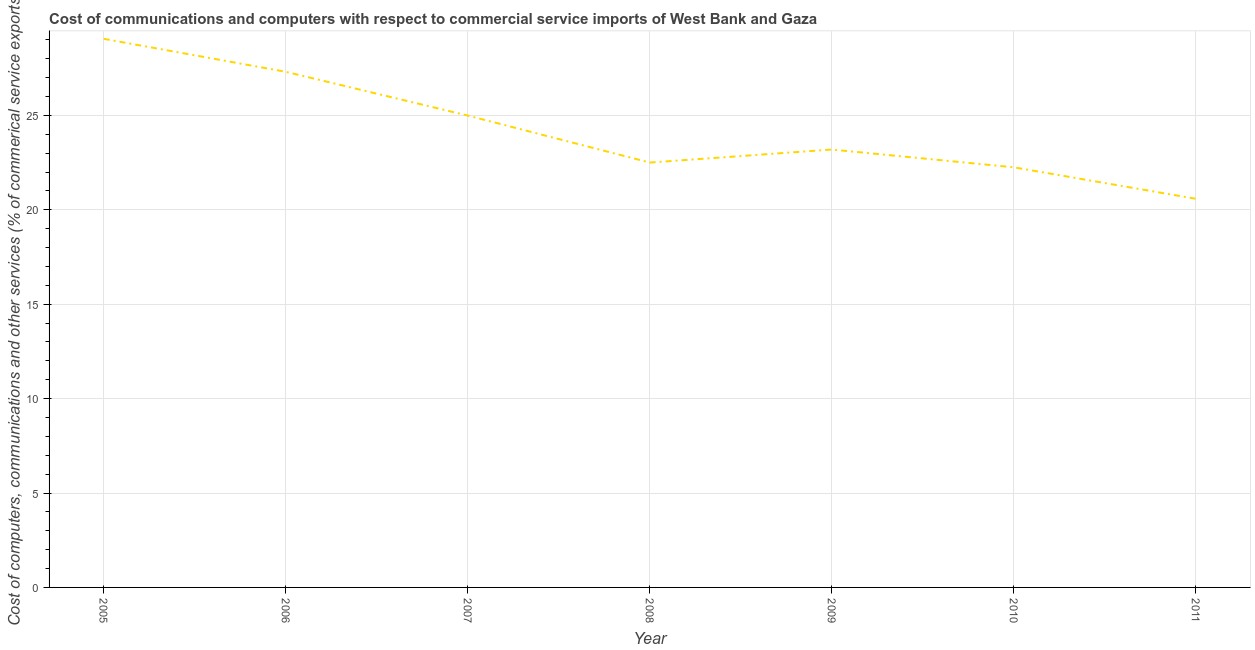What is the  computer and other services in 2011?
Keep it short and to the point. 20.58. Across all years, what is the maximum  computer and other services?
Your answer should be very brief. 29.06. Across all years, what is the minimum cost of communications?
Offer a terse response. 20.58. In which year was the  computer and other services minimum?
Make the answer very short. 2011. What is the sum of the  computer and other services?
Provide a short and direct response. 169.9. What is the difference between the cost of communications in 2005 and 2009?
Offer a terse response. 5.86. What is the average cost of communications per year?
Your answer should be very brief. 24.27. What is the median  computer and other services?
Keep it short and to the point. 23.19. In how many years, is the  computer and other services greater than 5 %?
Offer a terse response. 7. What is the ratio of the cost of communications in 2005 to that in 2010?
Make the answer very short. 1.31. What is the difference between the highest and the second highest cost of communications?
Your answer should be very brief. 1.75. Is the sum of the cost of communications in 2007 and 2008 greater than the maximum cost of communications across all years?
Your answer should be compact. Yes. What is the difference between the highest and the lowest  computer and other services?
Offer a very short reply. 8.47. How many years are there in the graph?
Give a very brief answer. 7. What is the difference between two consecutive major ticks on the Y-axis?
Keep it short and to the point. 5. Are the values on the major ticks of Y-axis written in scientific E-notation?
Give a very brief answer. No. Does the graph contain grids?
Make the answer very short. Yes. What is the title of the graph?
Give a very brief answer. Cost of communications and computers with respect to commercial service imports of West Bank and Gaza. What is the label or title of the X-axis?
Provide a short and direct response. Year. What is the label or title of the Y-axis?
Give a very brief answer. Cost of computers, communications and other services (% of commerical service exports). What is the Cost of computers, communications and other services (% of commerical service exports) in 2005?
Offer a very short reply. 29.06. What is the Cost of computers, communications and other services (% of commerical service exports) in 2006?
Give a very brief answer. 27.31. What is the Cost of computers, communications and other services (% of commerical service exports) in 2007?
Offer a terse response. 24.99. What is the Cost of computers, communications and other services (% of commerical service exports) of 2008?
Make the answer very short. 22.5. What is the Cost of computers, communications and other services (% of commerical service exports) of 2009?
Make the answer very short. 23.19. What is the Cost of computers, communications and other services (% of commerical service exports) in 2010?
Your answer should be very brief. 22.25. What is the Cost of computers, communications and other services (% of commerical service exports) in 2011?
Provide a short and direct response. 20.58. What is the difference between the Cost of computers, communications and other services (% of commerical service exports) in 2005 and 2006?
Offer a very short reply. 1.75. What is the difference between the Cost of computers, communications and other services (% of commerical service exports) in 2005 and 2007?
Make the answer very short. 4.07. What is the difference between the Cost of computers, communications and other services (% of commerical service exports) in 2005 and 2008?
Provide a short and direct response. 6.55. What is the difference between the Cost of computers, communications and other services (% of commerical service exports) in 2005 and 2009?
Offer a very short reply. 5.86. What is the difference between the Cost of computers, communications and other services (% of commerical service exports) in 2005 and 2010?
Ensure brevity in your answer.  6.81. What is the difference between the Cost of computers, communications and other services (% of commerical service exports) in 2005 and 2011?
Give a very brief answer. 8.47. What is the difference between the Cost of computers, communications and other services (% of commerical service exports) in 2006 and 2007?
Make the answer very short. 2.32. What is the difference between the Cost of computers, communications and other services (% of commerical service exports) in 2006 and 2008?
Provide a succinct answer. 4.81. What is the difference between the Cost of computers, communications and other services (% of commerical service exports) in 2006 and 2009?
Offer a terse response. 4.12. What is the difference between the Cost of computers, communications and other services (% of commerical service exports) in 2006 and 2010?
Make the answer very short. 5.06. What is the difference between the Cost of computers, communications and other services (% of commerical service exports) in 2006 and 2011?
Give a very brief answer. 6.73. What is the difference between the Cost of computers, communications and other services (% of commerical service exports) in 2007 and 2008?
Your answer should be compact. 2.49. What is the difference between the Cost of computers, communications and other services (% of commerical service exports) in 2007 and 2009?
Make the answer very short. 1.8. What is the difference between the Cost of computers, communications and other services (% of commerical service exports) in 2007 and 2010?
Give a very brief answer. 2.74. What is the difference between the Cost of computers, communications and other services (% of commerical service exports) in 2007 and 2011?
Make the answer very short. 4.41. What is the difference between the Cost of computers, communications and other services (% of commerical service exports) in 2008 and 2009?
Offer a very short reply. -0.69. What is the difference between the Cost of computers, communications and other services (% of commerical service exports) in 2008 and 2010?
Your answer should be very brief. 0.25. What is the difference between the Cost of computers, communications and other services (% of commerical service exports) in 2008 and 2011?
Your answer should be very brief. 1.92. What is the difference between the Cost of computers, communications and other services (% of commerical service exports) in 2009 and 2010?
Your answer should be very brief. 0.94. What is the difference between the Cost of computers, communications and other services (% of commerical service exports) in 2009 and 2011?
Make the answer very short. 2.61. What is the difference between the Cost of computers, communications and other services (% of commerical service exports) in 2010 and 2011?
Offer a terse response. 1.67. What is the ratio of the Cost of computers, communications and other services (% of commerical service exports) in 2005 to that in 2006?
Provide a succinct answer. 1.06. What is the ratio of the Cost of computers, communications and other services (% of commerical service exports) in 2005 to that in 2007?
Your answer should be very brief. 1.16. What is the ratio of the Cost of computers, communications and other services (% of commerical service exports) in 2005 to that in 2008?
Your answer should be very brief. 1.29. What is the ratio of the Cost of computers, communications and other services (% of commerical service exports) in 2005 to that in 2009?
Make the answer very short. 1.25. What is the ratio of the Cost of computers, communications and other services (% of commerical service exports) in 2005 to that in 2010?
Provide a succinct answer. 1.31. What is the ratio of the Cost of computers, communications and other services (% of commerical service exports) in 2005 to that in 2011?
Make the answer very short. 1.41. What is the ratio of the Cost of computers, communications and other services (% of commerical service exports) in 2006 to that in 2007?
Provide a succinct answer. 1.09. What is the ratio of the Cost of computers, communications and other services (% of commerical service exports) in 2006 to that in 2008?
Make the answer very short. 1.21. What is the ratio of the Cost of computers, communications and other services (% of commerical service exports) in 2006 to that in 2009?
Your answer should be very brief. 1.18. What is the ratio of the Cost of computers, communications and other services (% of commerical service exports) in 2006 to that in 2010?
Provide a succinct answer. 1.23. What is the ratio of the Cost of computers, communications and other services (% of commerical service exports) in 2006 to that in 2011?
Provide a succinct answer. 1.33. What is the ratio of the Cost of computers, communications and other services (% of commerical service exports) in 2007 to that in 2008?
Make the answer very short. 1.11. What is the ratio of the Cost of computers, communications and other services (% of commerical service exports) in 2007 to that in 2009?
Your answer should be very brief. 1.08. What is the ratio of the Cost of computers, communications and other services (% of commerical service exports) in 2007 to that in 2010?
Give a very brief answer. 1.12. What is the ratio of the Cost of computers, communications and other services (% of commerical service exports) in 2007 to that in 2011?
Provide a short and direct response. 1.21. What is the ratio of the Cost of computers, communications and other services (% of commerical service exports) in 2008 to that in 2011?
Ensure brevity in your answer.  1.09. What is the ratio of the Cost of computers, communications and other services (% of commerical service exports) in 2009 to that in 2010?
Offer a very short reply. 1.04. What is the ratio of the Cost of computers, communications and other services (% of commerical service exports) in 2009 to that in 2011?
Your answer should be very brief. 1.13. What is the ratio of the Cost of computers, communications and other services (% of commerical service exports) in 2010 to that in 2011?
Give a very brief answer. 1.08. 